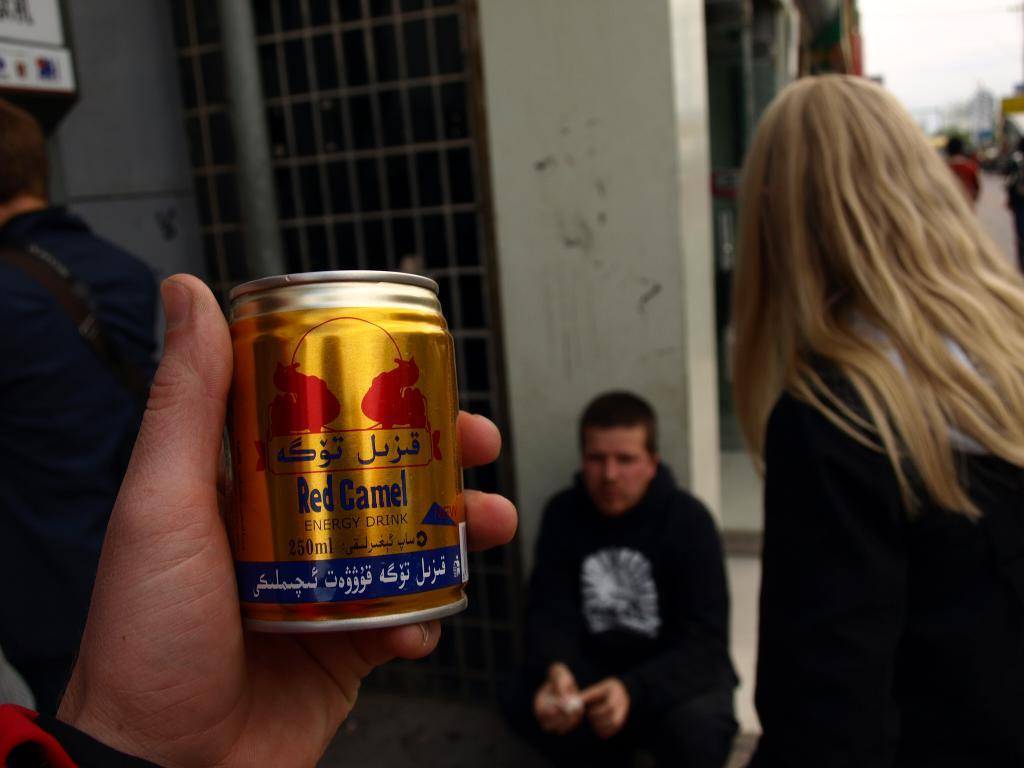What is the person holding in the image? The fact does not specify what the person is holding, so we cannot definitively answer this question. Can you describe the people in the background of the image? There are other people visible in the background of the image, but their specific characteristics are not mentioned in the facts. What objects can be seen in the background of the image? There are unspecified objects in the background of the image, so we cannot provide a detailed description of them. How is the background of the image depicted? The background of the image is blurred. What type of pollution is visible in the image? There is no mention of pollution in the image, so we cannot answer this question. How many cherries are on the person's hat in the image? There is no mention of a hat or cherries in the image, so we cannot answer this question. 